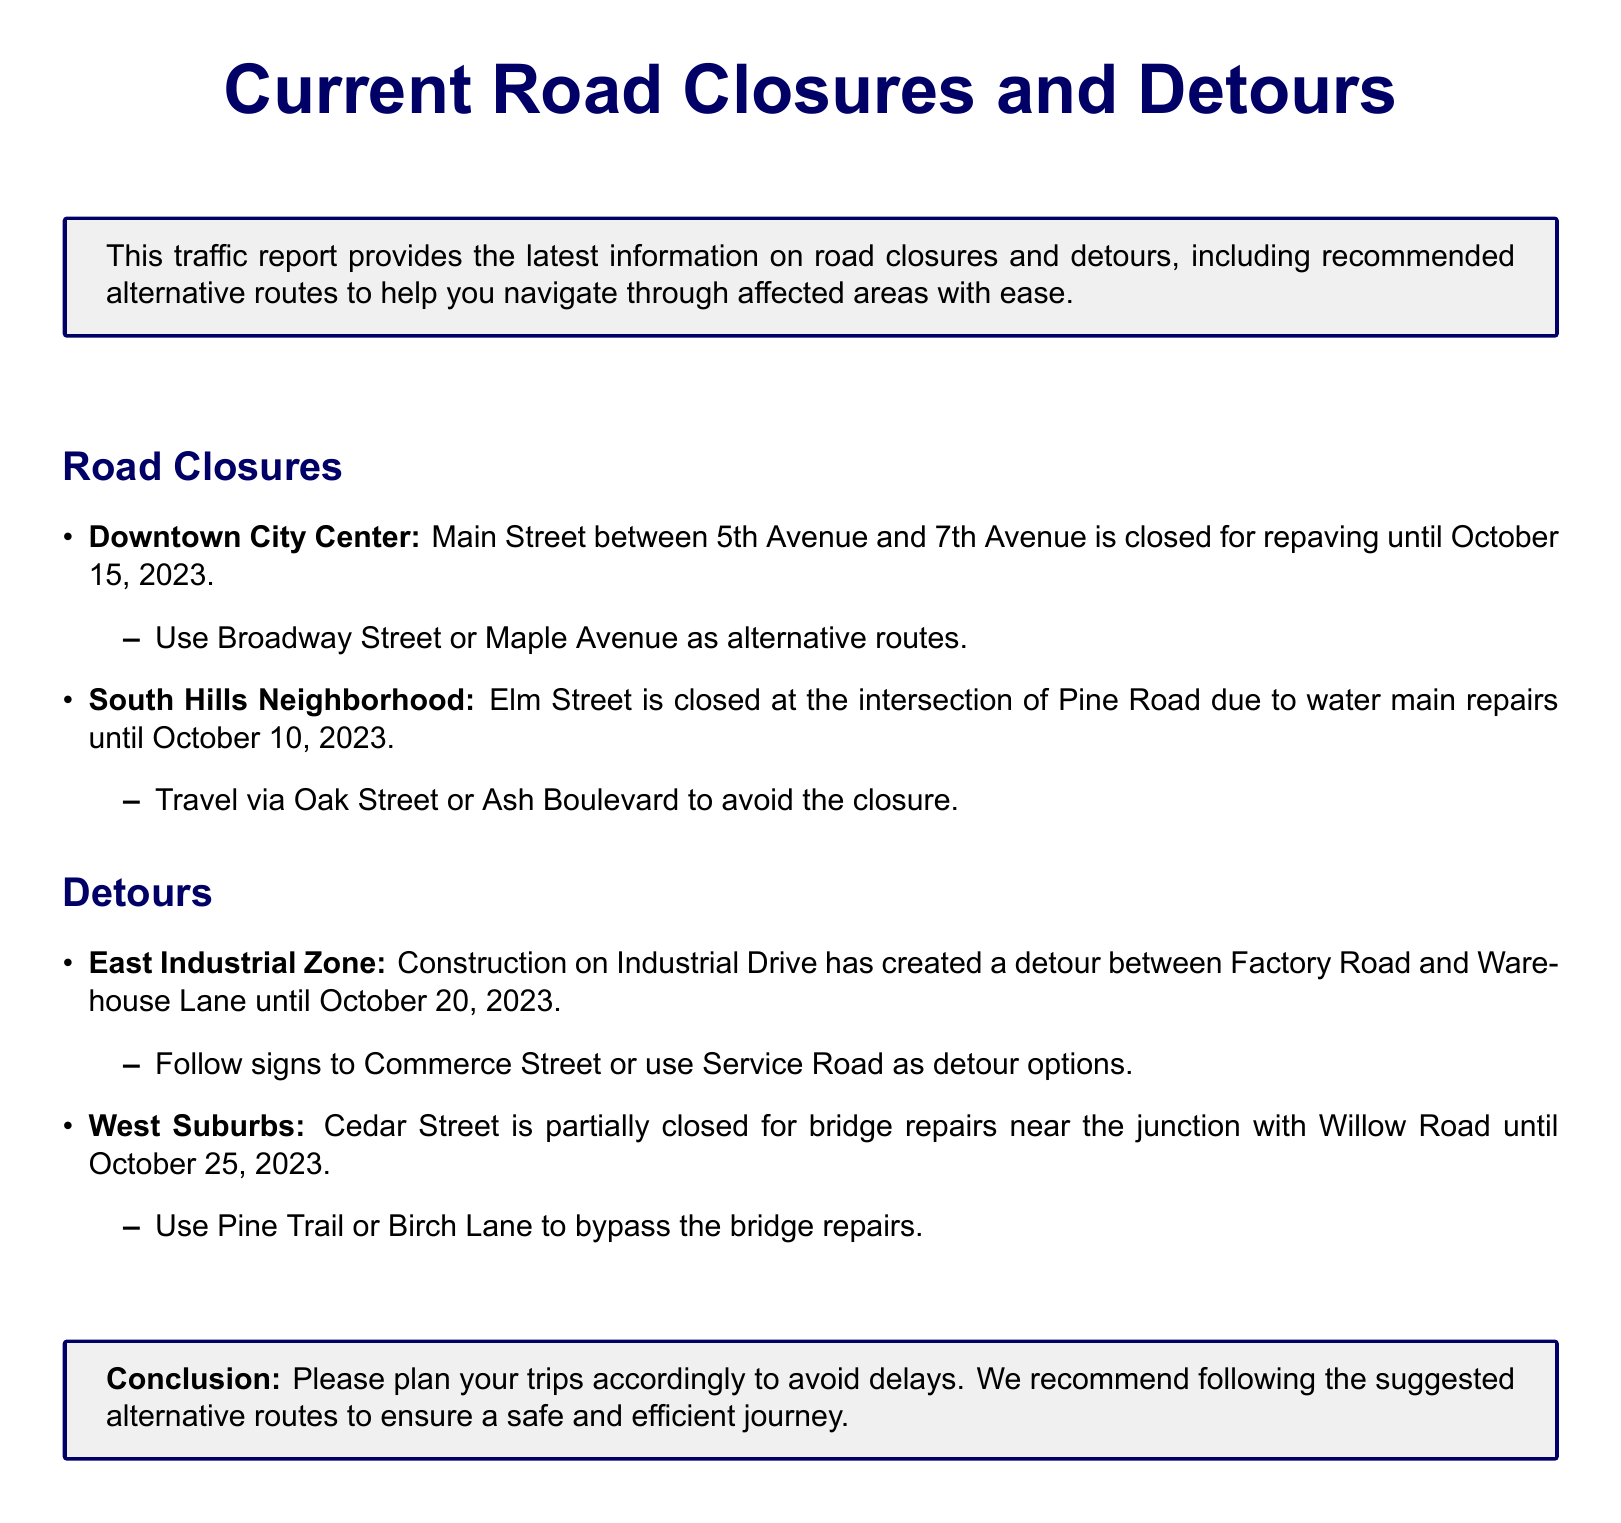What street is closed in Downtown City Center? The document specifies that Main Street is closed between 5th Avenue and 7th Avenue.
Answer: Main Street Until what date is the road closure in South Hills Neighborhood? The closure of Elm Street is indicated to last until October 10, 2023.
Answer: October 10, 2023 What is the alternative route suggested for the Downtown City Center closure? The document recommends Broadway Street or Maple Avenue as the alternative routes.
Answer: Broadway Street or Maple Avenue What type of repairs is taking place on Elm Street? The document mentions that the closure is due to water main repairs.
Answer: Water main repairs What is the duration of the detour in the East Industrial Zone? The detour will be in effect until October 20, 2023, according to the document.
Answer: October 20, 2023 Which street should be used to detour around the partial closure on Cedar Street? The suggested alternatives to bypass the bridge repairs are Pine Trail or Birch Lane.
Answer: Pine Trail or Birch Lane What is the main purpose of this traffic report? The document states its purpose is to provide information on road closures and suggest alternative routes.
Answer: Provide information on road closures How many road closures are listed in the document? The document lists two road closures, one in Downtown City Center and one in South Hills Neighborhood.
Answer: Two What is suggested to avoid delays according to the conclusion? The conclusion recommends following the suggested alternative routes to avoid delays.
Answer: Suggested alternative routes 